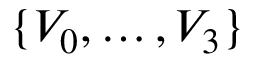<formula> <loc_0><loc_0><loc_500><loc_500>\{ V _ { 0 } , \dots , V _ { 3 } \}</formula> 